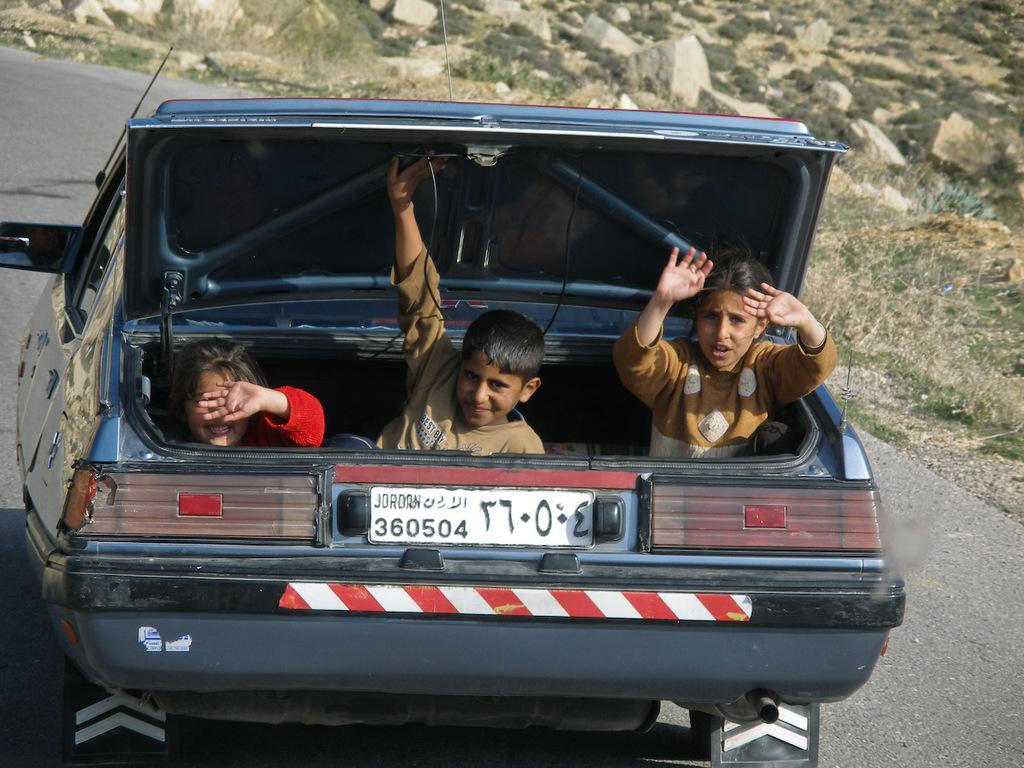How many kids are in the car in the image? There are three kids in the car. Where is the car located in the image? The car is on the road. Reasoning: Let's think step by identifying the main subjects and objects in the image based on the provided facts. We then formulate questions that focus on the location and characteristics of these subjects and objects, ensuring that each question can be answered definitively with the information given. We avoid yes/no questions and ensure that the language is simple and clear. Absurd Question/Answer: What type of berry can be seen growing on the side of the road in the image? There is no berry plant or berries visible in the image; it only shows a car with three kids on the road. What type of texture can be seen on the plantation in the image? There is no plantation present in the image; it only shows a car with three kids on the road. 